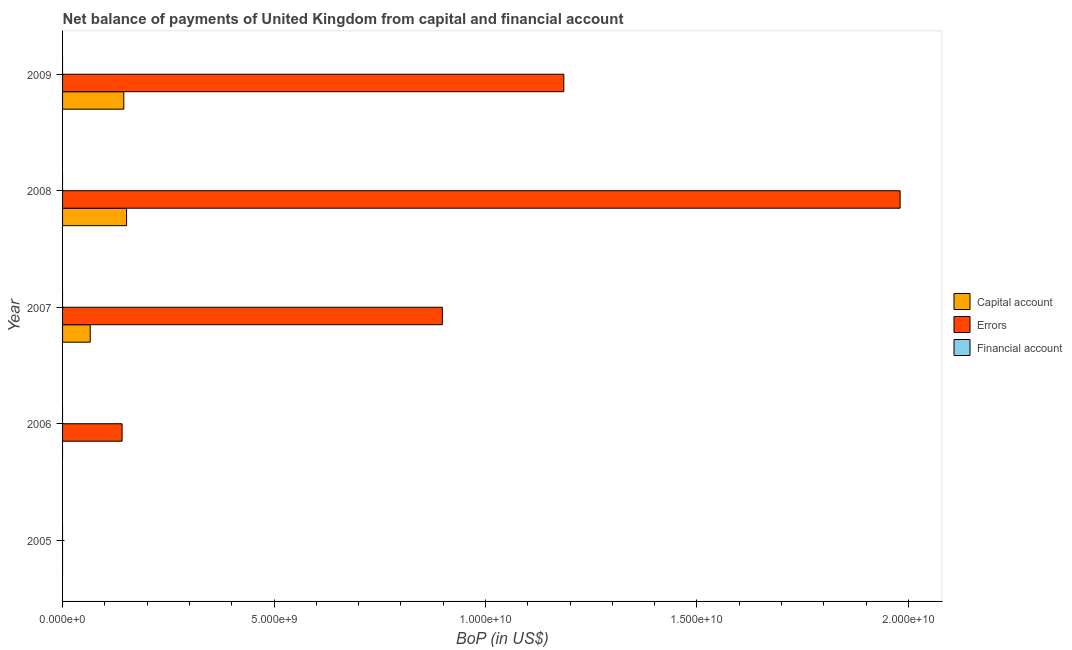How many bars are there on the 4th tick from the bottom?
Offer a terse response. 2. What is the label of the 3rd group of bars from the top?
Make the answer very short. 2007. Across all years, what is the maximum amount of net capital account?
Offer a terse response. 1.51e+09. What is the total amount of net capital account in the graph?
Give a very brief answer. 3.62e+09. What is the difference between the amount of errors in 2006 and that in 2009?
Your answer should be compact. -1.04e+1. What is the difference between the amount of financial account in 2006 and the amount of net capital account in 2008?
Provide a short and direct response. -1.51e+09. What is the average amount of errors per year?
Ensure brevity in your answer.  8.41e+09. In the year 2008, what is the difference between the amount of net capital account and amount of errors?
Make the answer very short. -1.83e+1. What is the ratio of the amount of net capital account in 2007 to that in 2008?
Your response must be concise. 0.43. Is the amount of errors in 2007 less than that in 2008?
Offer a very short reply. Yes. What is the difference between the highest and the second highest amount of net capital account?
Provide a succinct answer. 6.58e+07. What is the difference between the highest and the lowest amount of errors?
Ensure brevity in your answer.  1.98e+1. In how many years, is the amount of net capital account greater than the average amount of net capital account taken over all years?
Offer a very short reply. 2. Is the sum of the amount of errors in 2008 and 2009 greater than the maximum amount of net capital account across all years?
Your answer should be very brief. Yes. Is it the case that in every year, the sum of the amount of net capital account and amount of errors is greater than the amount of financial account?
Your answer should be compact. No. How many bars are there?
Your answer should be compact. 7. What is the difference between two consecutive major ticks on the X-axis?
Make the answer very short. 5.00e+09. Are the values on the major ticks of X-axis written in scientific E-notation?
Offer a terse response. Yes. Does the graph contain any zero values?
Your answer should be very brief. Yes. Where does the legend appear in the graph?
Keep it short and to the point. Center right. What is the title of the graph?
Ensure brevity in your answer.  Net balance of payments of United Kingdom from capital and financial account. Does "Poland" appear as one of the legend labels in the graph?
Your response must be concise. No. What is the label or title of the X-axis?
Give a very brief answer. BoP (in US$). What is the BoP (in US$) in Capital account in 2006?
Give a very brief answer. 0. What is the BoP (in US$) in Errors in 2006?
Make the answer very short. 1.41e+09. What is the BoP (in US$) of Capital account in 2007?
Ensure brevity in your answer.  6.54e+08. What is the BoP (in US$) of Errors in 2007?
Your answer should be very brief. 8.98e+09. What is the BoP (in US$) in Financial account in 2007?
Ensure brevity in your answer.  0. What is the BoP (in US$) in Capital account in 2008?
Give a very brief answer. 1.51e+09. What is the BoP (in US$) in Errors in 2008?
Offer a very short reply. 1.98e+1. What is the BoP (in US$) of Capital account in 2009?
Make the answer very short. 1.45e+09. What is the BoP (in US$) of Errors in 2009?
Offer a very short reply. 1.19e+1. Across all years, what is the maximum BoP (in US$) of Capital account?
Keep it short and to the point. 1.51e+09. Across all years, what is the maximum BoP (in US$) of Errors?
Your answer should be compact. 1.98e+1. What is the total BoP (in US$) in Capital account in the graph?
Keep it short and to the point. 3.62e+09. What is the total BoP (in US$) of Errors in the graph?
Keep it short and to the point. 4.20e+1. What is the difference between the BoP (in US$) in Errors in 2006 and that in 2007?
Offer a very short reply. -7.57e+09. What is the difference between the BoP (in US$) of Errors in 2006 and that in 2008?
Offer a very short reply. -1.84e+1. What is the difference between the BoP (in US$) of Errors in 2006 and that in 2009?
Your answer should be compact. -1.04e+1. What is the difference between the BoP (in US$) in Capital account in 2007 and that in 2008?
Provide a short and direct response. -8.60e+08. What is the difference between the BoP (in US$) of Errors in 2007 and that in 2008?
Your response must be concise. -1.08e+1. What is the difference between the BoP (in US$) in Capital account in 2007 and that in 2009?
Your answer should be very brief. -7.94e+08. What is the difference between the BoP (in US$) of Errors in 2007 and that in 2009?
Provide a succinct answer. -2.87e+09. What is the difference between the BoP (in US$) in Capital account in 2008 and that in 2009?
Ensure brevity in your answer.  6.58e+07. What is the difference between the BoP (in US$) of Errors in 2008 and that in 2009?
Keep it short and to the point. 7.95e+09. What is the difference between the BoP (in US$) in Capital account in 2007 and the BoP (in US$) in Errors in 2008?
Offer a terse response. -1.92e+1. What is the difference between the BoP (in US$) in Capital account in 2007 and the BoP (in US$) in Errors in 2009?
Provide a short and direct response. -1.12e+1. What is the difference between the BoP (in US$) of Capital account in 2008 and the BoP (in US$) of Errors in 2009?
Your response must be concise. -1.03e+1. What is the average BoP (in US$) of Capital account per year?
Give a very brief answer. 7.23e+08. What is the average BoP (in US$) in Errors per year?
Offer a very short reply. 8.41e+09. In the year 2007, what is the difference between the BoP (in US$) of Capital account and BoP (in US$) of Errors?
Offer a very short reply. -8.33e+09. In the year 2008, what is the difference between the BoP (in US$) of Capital account and BoP (in US$) of Errors?
Your answer should be compact. -1.83e+1. In the year 2009, what is the difference between the BoP (in US$) of Capital account and BoP (in US$) of Errors?
Keep it short and to the point. -1.04e+1. What is the ratio of the BoP (in US$) in Errors in 2006 to that in 2007?
Give a very brief answer. 0.16. What is the ratio of the BoP (in US$) of Errors in 2006 to that in 2008?
Make the answer very short. 0.07. What is the ratio of the BoP (in US$) in Errors in 2006 to that in 2009?
Your response must be concise. 0.12. What is the ratio of the BoP (in US$) of Capital account in 2007 to that in 2008?
Your answer should be compact. 0.43. What is the ratio of the BoP (in US$) in Errors in 2007 to that in 2008?
Your answer should be compact. 0.45. What is the ratio of the BoP (in US$) of Capital account in 2007 to that in 2009?
Provide a short and direct response. 0.45. What is the ratio of the BoP (in US$) in Errors in 2007 to that in 2009?
Your answer should be very brief. 0.76. What is the ratio of the BoP (in US$) in Capital account in 2008 to that in 2009?
Your response must be concise. 1.05. What is the ratio of the BoP (in US$) of Errors in 2008 to that in 2009?
Offer a terse response. 1.67. What is the difference between the highest and the second highest BoP (in US$) in Capital account?
Give a very brief answer. 6.58e+07. What is the difference between the highest and the second highest BoP (in US$) of Errors?
Provide a succinct answer. 7.95e+09. What is the difference between the highest and the lowest BoP (in US$) of Capital account?
Keep it short and to the point. 1.51e+09. What is the difference between the highest and the lowest BoP (in US$) in Errors?
Your answer should be very brief. 1.98e+1. 